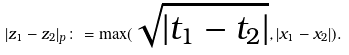Convert formula to latex. <formula><loc_0><loc_0><loc_500><loc_500>| z _ { 1 } - z _ { 2 } | _ { p } \colon = \max ( \sqrt { | t _ { 1 } - t _ { 2 } | } , | x _ { 1 } - x _ { 2 } | ) .</formula> 